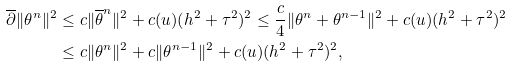Convert formula to latex. <formula><loc_0><loc_0><loc_500><loc_500>\overline { \partial } \| \theta ^ { n } \| ^ { 2 } & \leq c \| \overline { \theta } ^ { n } \| ^ { 2 } + c ( u ) ( h ^ { 2 } + \tau ^ { 2 } ) ^ { 2 } \leq \frac { c } { 4 } \| \theta ^ { n } + \theta ^ { n - 1 } \| ^ { 2 } + c ( u ) ( h ^ { 2 } + \tau ^ { 2 } ) ^ { 2 } \\ & \leq c \| \theta ^ { n } \| ^ { 2 } + c \| \theta ^ { n - 1 } \| ^ { 2 } + c ( u ) ( h ^ { 2 } + \tau ^ { 2 } ) ^ { 2 } ,</formula> 